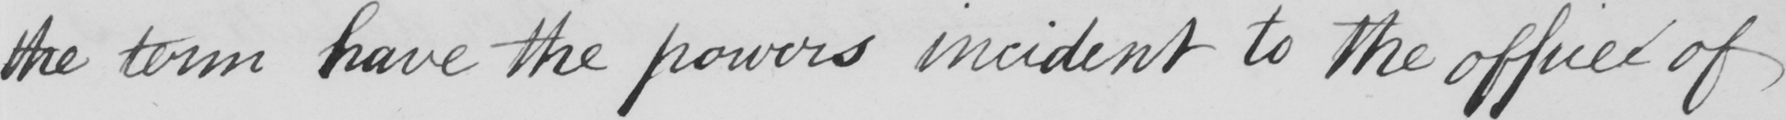Can you tell me what this handwritten text says? the term have the powers incident to the office of 